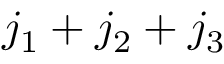Convert formula to latex. <formula><loc_0><loc_0><loc_500><loc_500>{ j _ { 1 } + j _ { 2 } + j _ { 3 } }</formula> 